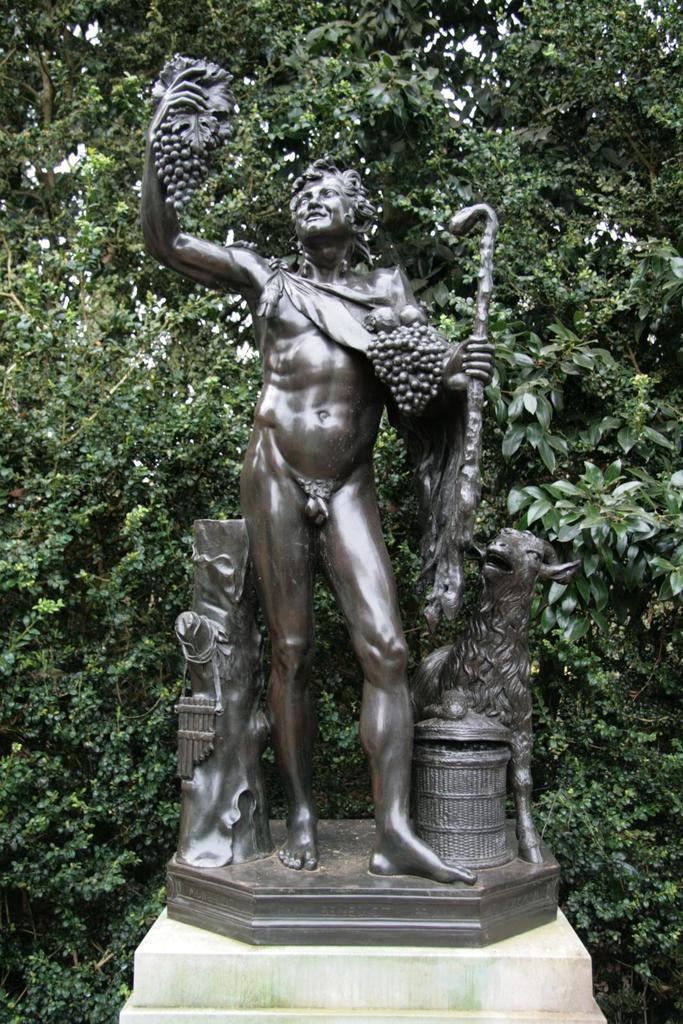Please provide a concise description of this image. In this image we can see a tree. There is a statue of a person in the image. 